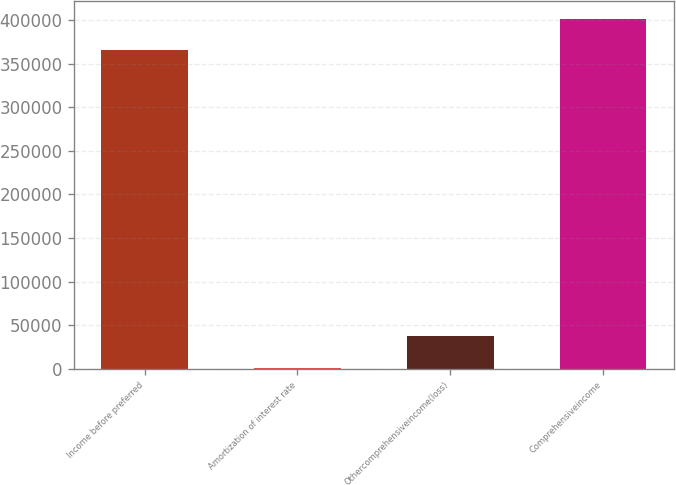Convert chart. <chart><loc_0><loc_0><loc_500><loc_500><bar_chart><fcel>Income before preferred<fcel>Amortization of interest rate<fcel>Othercomprehensiveincome(loss)<fcel>Comprehensiveincome<nl><fcel>365322<fcel>683<fcel>37215.2<fcel>401854<nl></chart> 